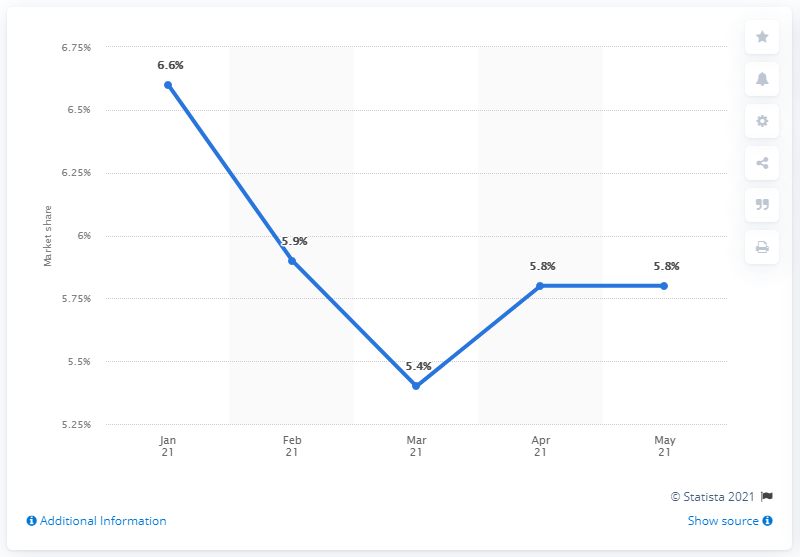Outline some significant characteristics in this image. According to the data available for May 2021, Toyota accounted for 5.8% of all new car registrations in the European Union. 